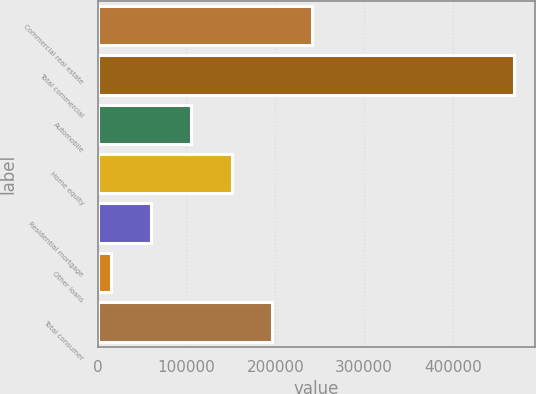Convert chart to OTSL. <chart><loc_0><loc_0><loc_500><loc_500><bar_chart><fcel>Commercial real estate<fcel>Total commercial<fcel>Automobile<fcel>Home equity<fcel>Residential mortgage<fcel>Other loans<fcel>Total consumer<nl><fcel>241552<fcel>468553<fcel>105351<fcel>150752<fcel>59951.2<fcel>14551<fcel>196152<nl></chart> 